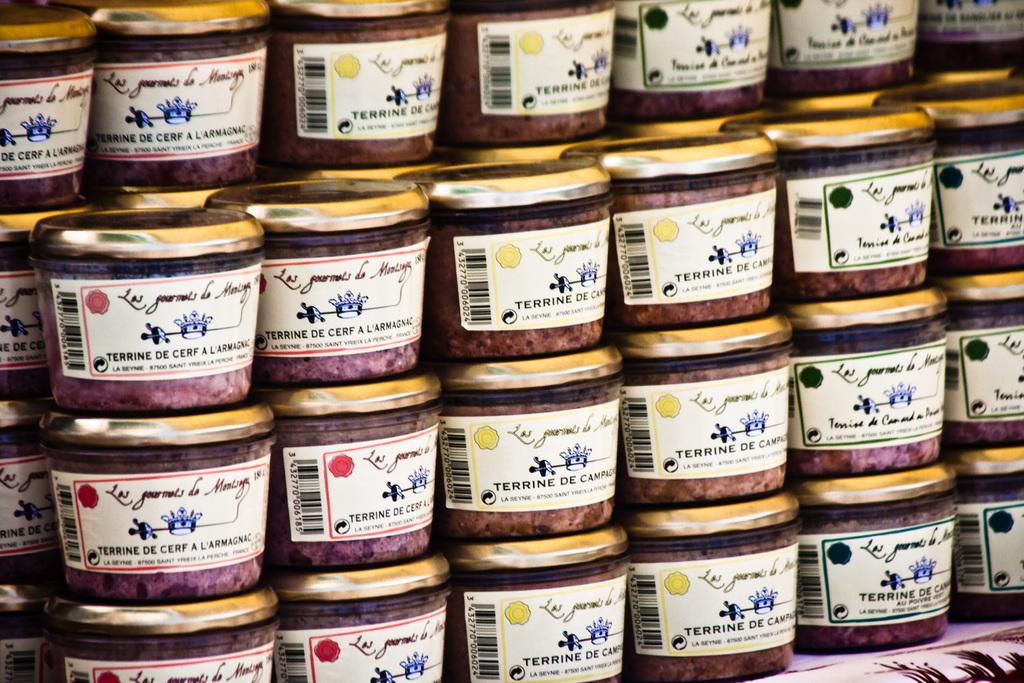What is in the jars?
Provide a short and direct response. Terrine de cerf. 